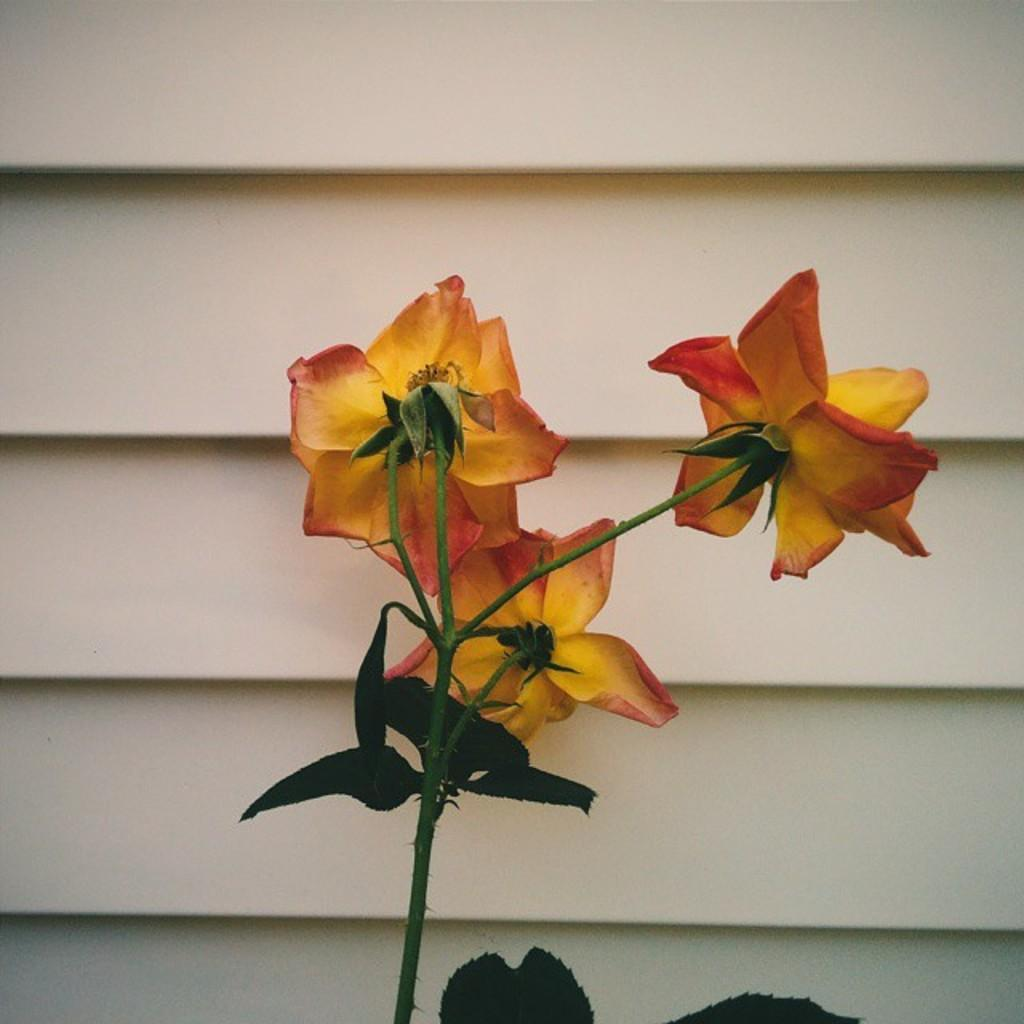What type of plant is visible in the image? There is a plant in the image. What features of the plant can be observed? The plant has flowers and leaves. What is located behind the flowers in the image? There is a wall behind the flowers in the image. What type of zephyr is blowing the flowers in the image? There is no zephyr present in the image, and the flowers are not being blown. 